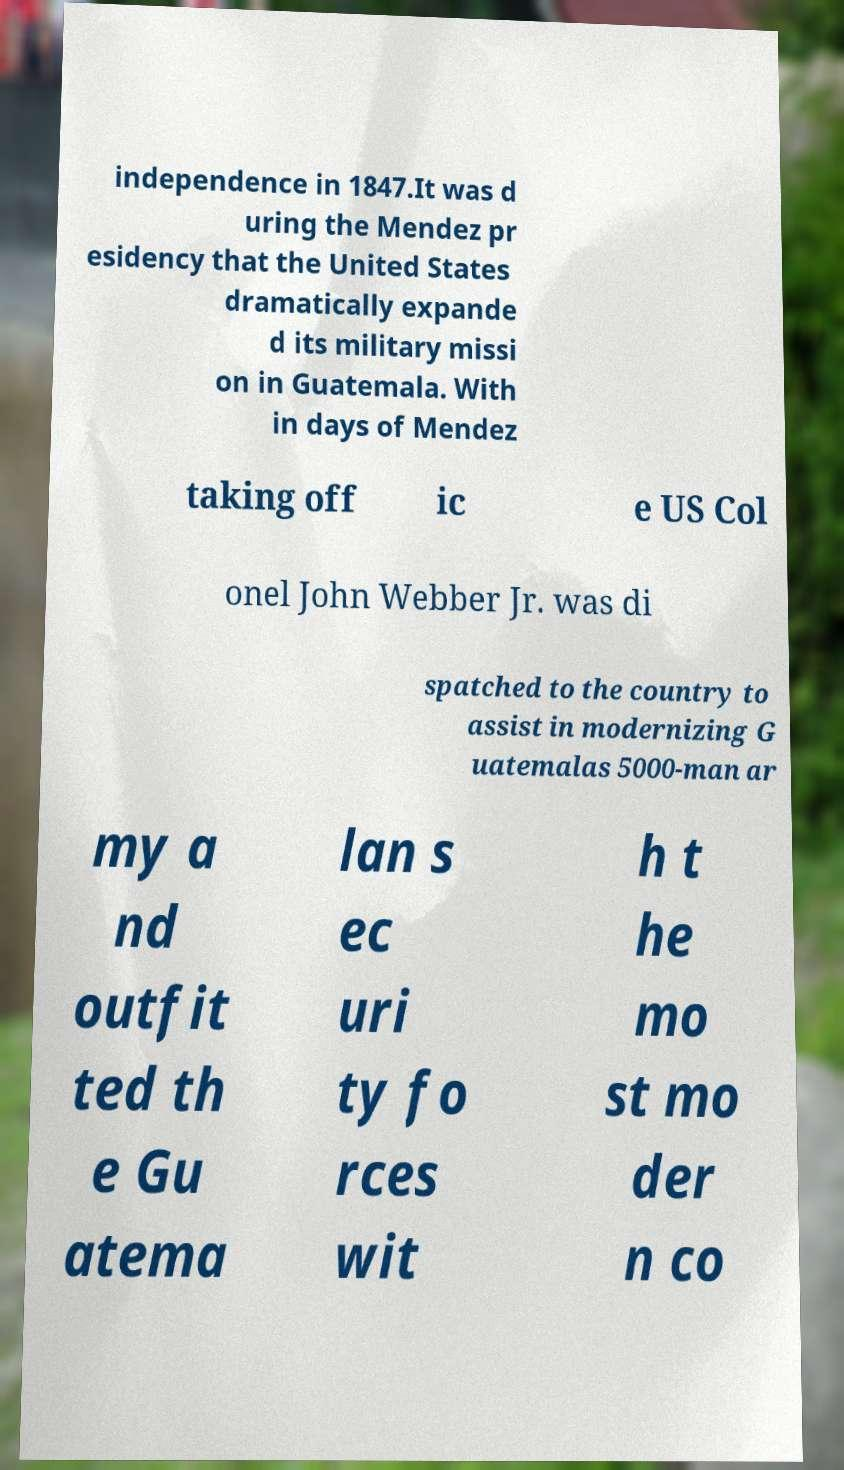Could you assist in decoding the text presented in this image and type it out clearly? independence in 1847.It was d uring the Mendez pr esidency that the United States dramatically expande d its military missi on in Guatemala. With in days of Mendez taking off ic e US Col onel John Webber Jr. was di spatched to the country to assist in modernizing G uatemalas 5000-man ar my a nd outfit ted th e Gu atema lan s ec uri ty fo rces wit h t he mo st mo der n co 